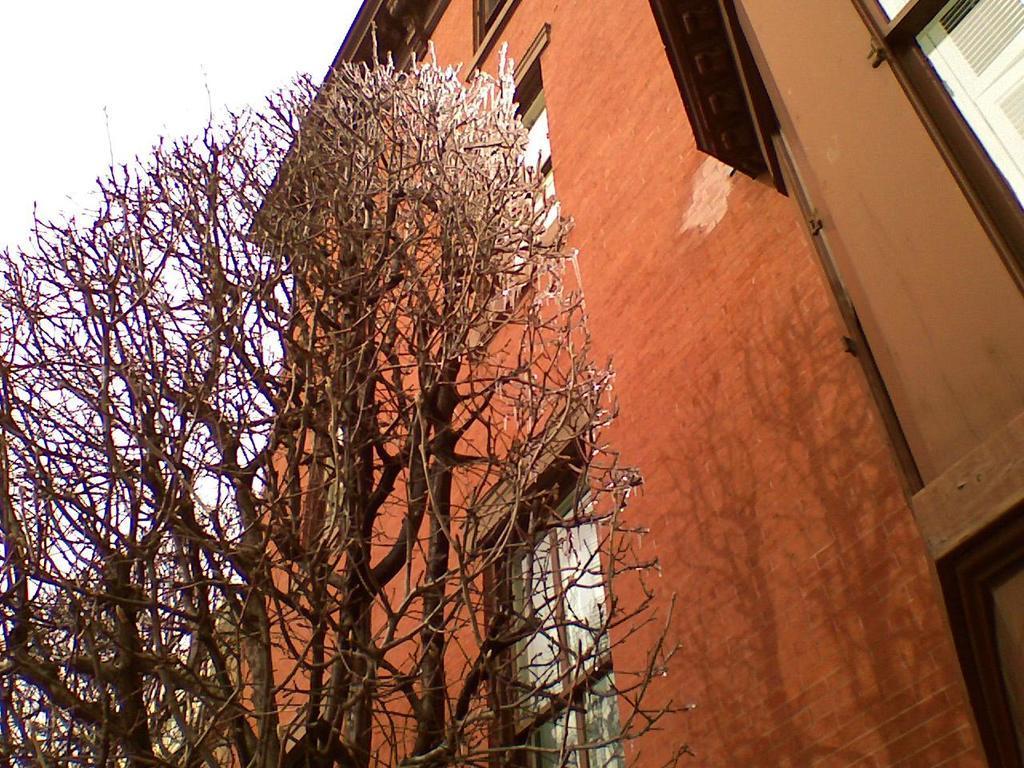How would you summarize this image in a sentence or two? This is an outside view. On the right side, I can see a building along with the windows. On the left side there is a tree. At the top of the image I can see the sky. 